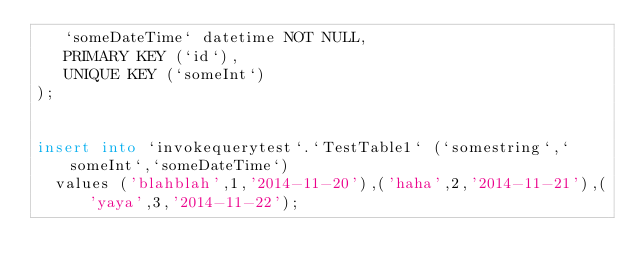Convert code to text. <code><loc_0><loc_0><loc_500><loc_500><_SQL_>   `someDateTime` datetime NOT NULL,
   PRIMARY KEY (`id`),
   UNIQUE KEY (`someInt`)
);


insert into `invokequerytest`.`TestTable1` (`somestring`,`someInt`,`someDateTime`)
	values ('blahblah',1,'2014-11-20'),('haha',2,'2014-11-21'),('yaya',3,'2014-11-22');
	
	</code> 